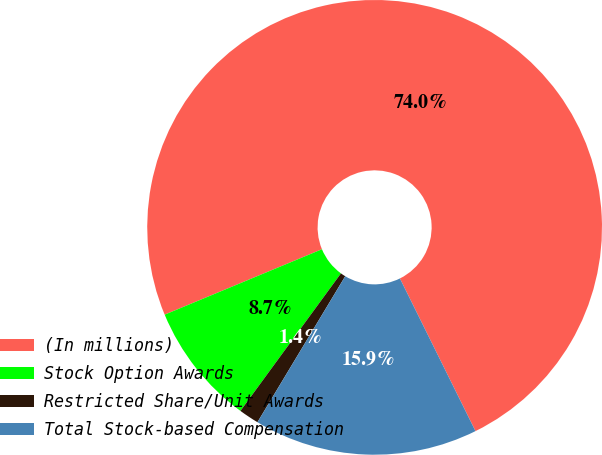<chart> <loc_0><loc_0><loc_500><loc_500><pie_chart><fcel>(In millions)<fcel>Stock Option Awards<fcel>Restricted Share/Unit Awards<fcel>Total Stock-based Compensation<nl><fcel>73.95%<fcel>8.68%<fcel>1.43%<fcel>15.93%<nl></chart> 